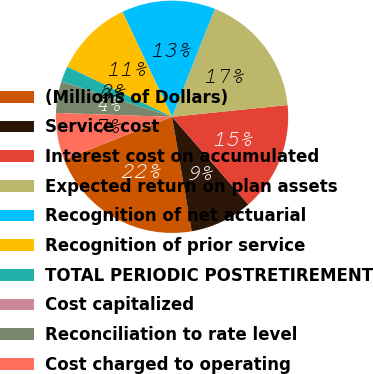Convert chart. <chart><loc_0><loc_0><loc_500><loc_500><pie_chart><fcel>(Millions of Dollars)<fcel>Service cost<fcel>Interest cost on accumulated<fcel>Expected return on plan assets<fcel>Recognition of net actuarial<fcel>Recognition of prior service<fcel>TOTAL PERIODIC POSTRETIREMENT<fcel>Cost capitalized<fcel>Reconciliation to rate level<fcel>Cost charged to operating<nl><fcel>21.71%<fcel>8.7%<fcel>15.21%<fcel>17.38%<fcel>13.04%<fcel>10.87%<fcel>2.19%<fcel>0.02%<fcel>4.36%<fcel>6.53%<nl></chart> 